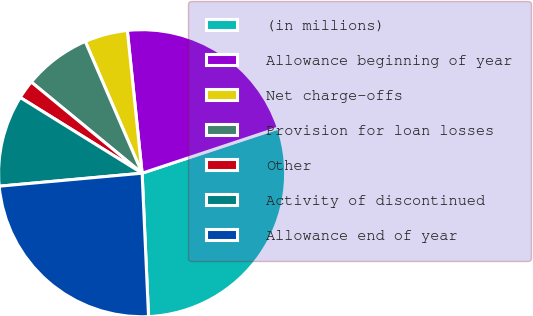Convert chart. <chart><loc_0><loc_0><loc_500><loc_500><pie_chart><fcel>(in millions)<fcel>Allowance beginning of year<fcel>Net charge-offs<fcel>Provision for loan losses<fcel>Other<fcel>Activity of discontinued<fcel>Allowance end of year<nl><fcel>29.39%<fcel>21.54%<fcel>4.84%<fcel>7.56%<fcel>2.11%<fcel>10.29%<fcel>24.27%<nl></chart> 